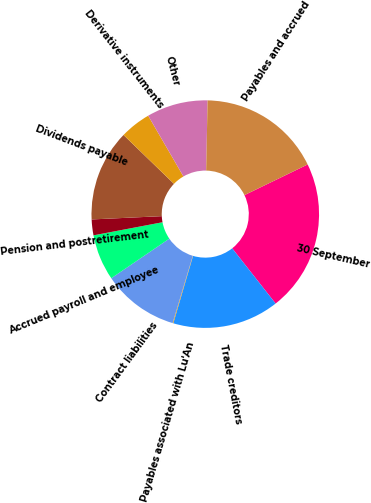Convert chart to OTSL. <chart><loc_0><loc_0><loc_500><loc_500><pie_chart><fcel>30 September<fcel>Trade creditors<fcel>Payables associated with Lu'An<fcel>Contract liabilities<fcel>Accrued payroll and employee<fcel>Pension and postretirement<fcel>Dividends payable<fcel>Derivative instruments<fcel>Other<fcel>Payables and accrued<nl><fcel>21.58%<fcel>15.14%<fcel>0.1%<fcel>10.84%<fcel>6.54%<fcel>2.24%<fcel>12.99%<fcel>4.39%<fcel>8.69%<fcel>17.49%<nl></chart> 